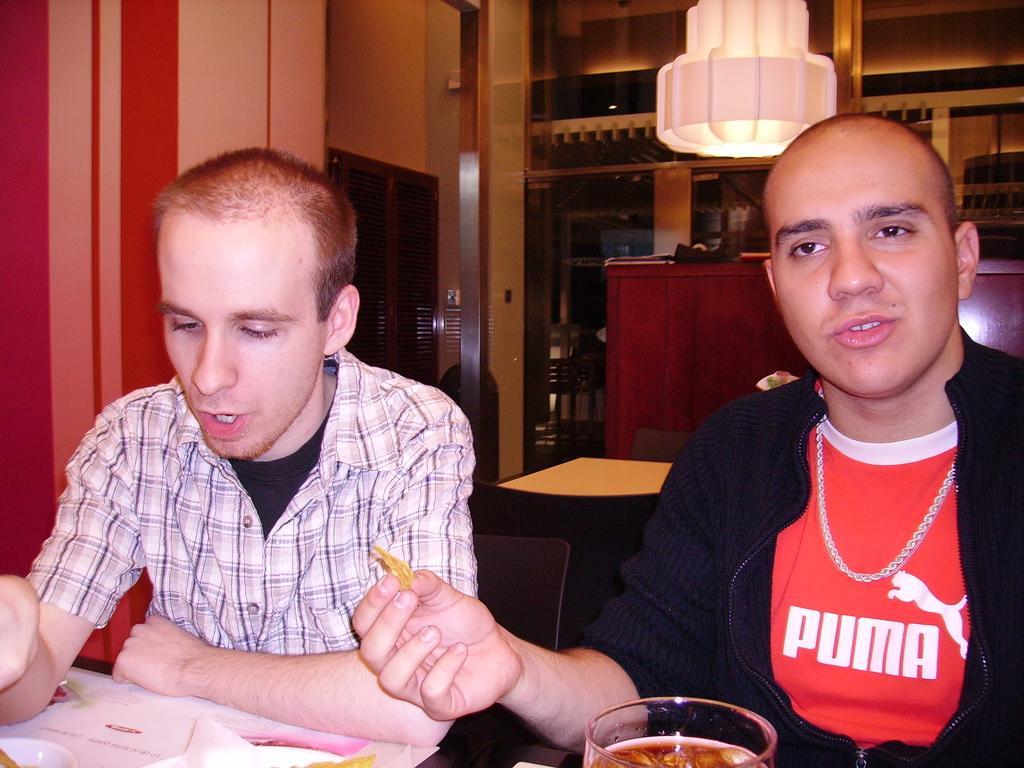Could you give a brief overview of what you see in this image? In this picture there is a man with black jacket is sitting and holding the food and there is another man sitting. In the foreground there are bowls and there is a glass and there are papers on the table. At the back there is a table and there are chairs and there is a cupboard and there are objects on the cupboard. At the top there is a chandelier. On the left side of the image it looks like a cupboard. 